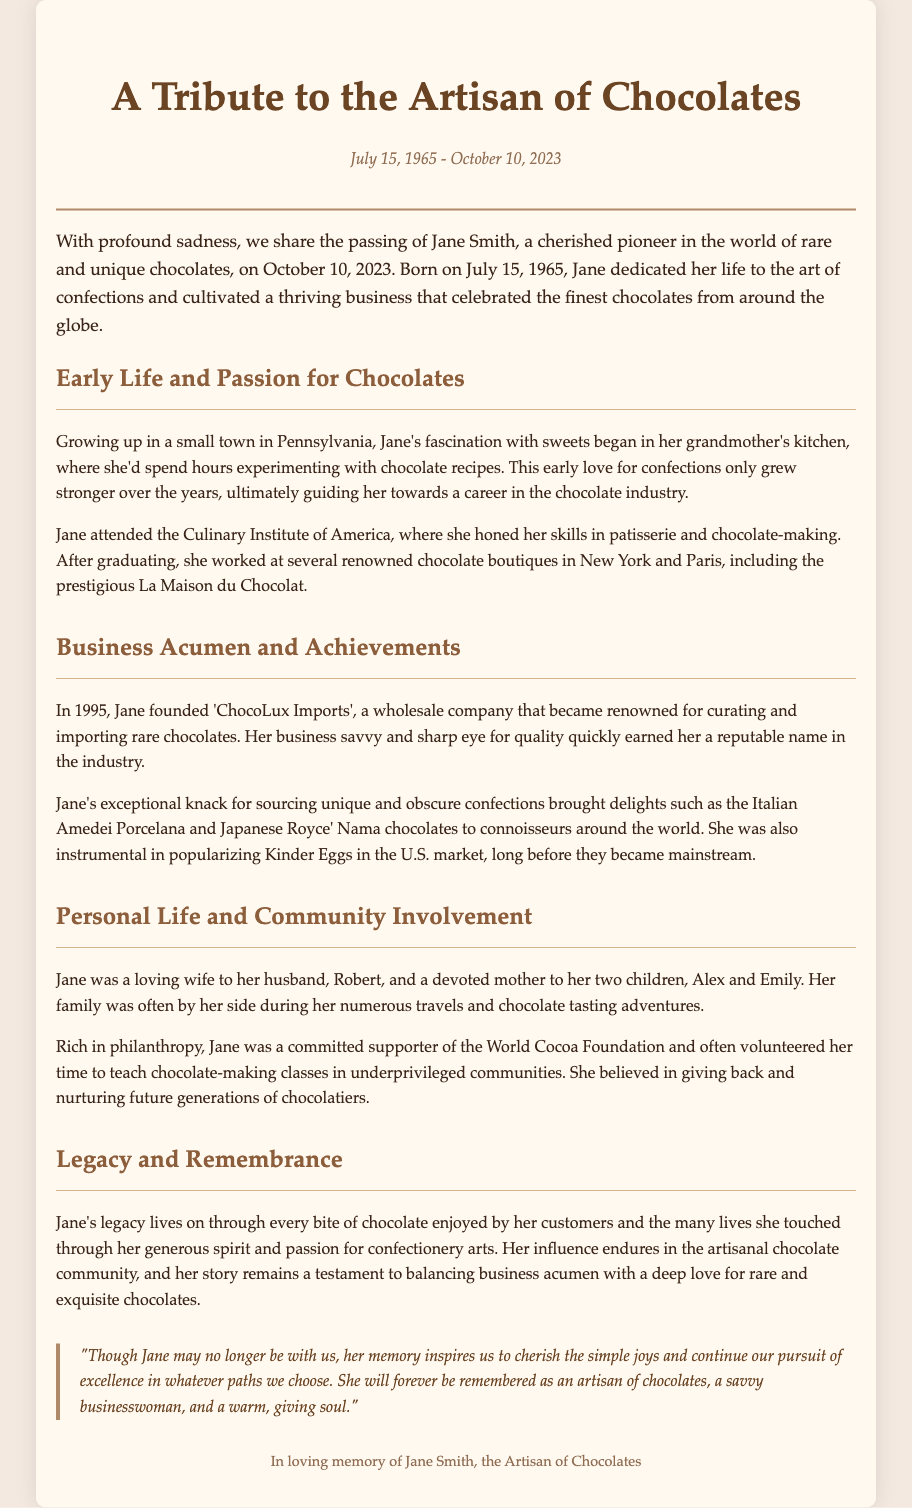What date did Jane Smith pass away? The date of Jane Smith's passing is stated in the document as October 10, 2023.
Answer: October 10, 2023 What was the name of Jane's company? The document explicitly mentions the name of Jane's company as 'ChocoLux Imports'.
Answer: ChocoLux Imports In which year was 'ChocoLux Imports' founded? The document provides the founding year of 'ChocoLux Imports' as 1995.
Answer: 1995 What was Jane's degree specialization? The document indicates that Jane specialized in patisserie and chocolate-making at the Culinary Institute of America.
Answer: Patisserie and chocolate-making What influence did Jane have on the U.S. market? The document states that she was instrumental in popularizing Kinder Eggs in the U.S. market.
Answer: Popularizing Kinder Eggs What was one of Jane's philanthropic activities? The document highlights that she volunteered to teach chocolate-making classes in underprivileged communities.
Answer: Teaching chocolate-making classes How did Jane's early life influence her career choice? The document explains that Jane's fascination with sweets began in her grandmother's kitchen, leading her to a career in the chocolate industry.
Answer: Grandmother's kitchen What does the document say about Jane's family? The document describes Jane as a loving wife and devoted mother to two children, Alex and Emily.
Answer: Loving wife and devoted mother What is Jane's legacy in the chocolate community? The document mentions that her legacy lives on through every bite of chocolate enjoyed by her customers.
Answer: Every bite of chocolate 